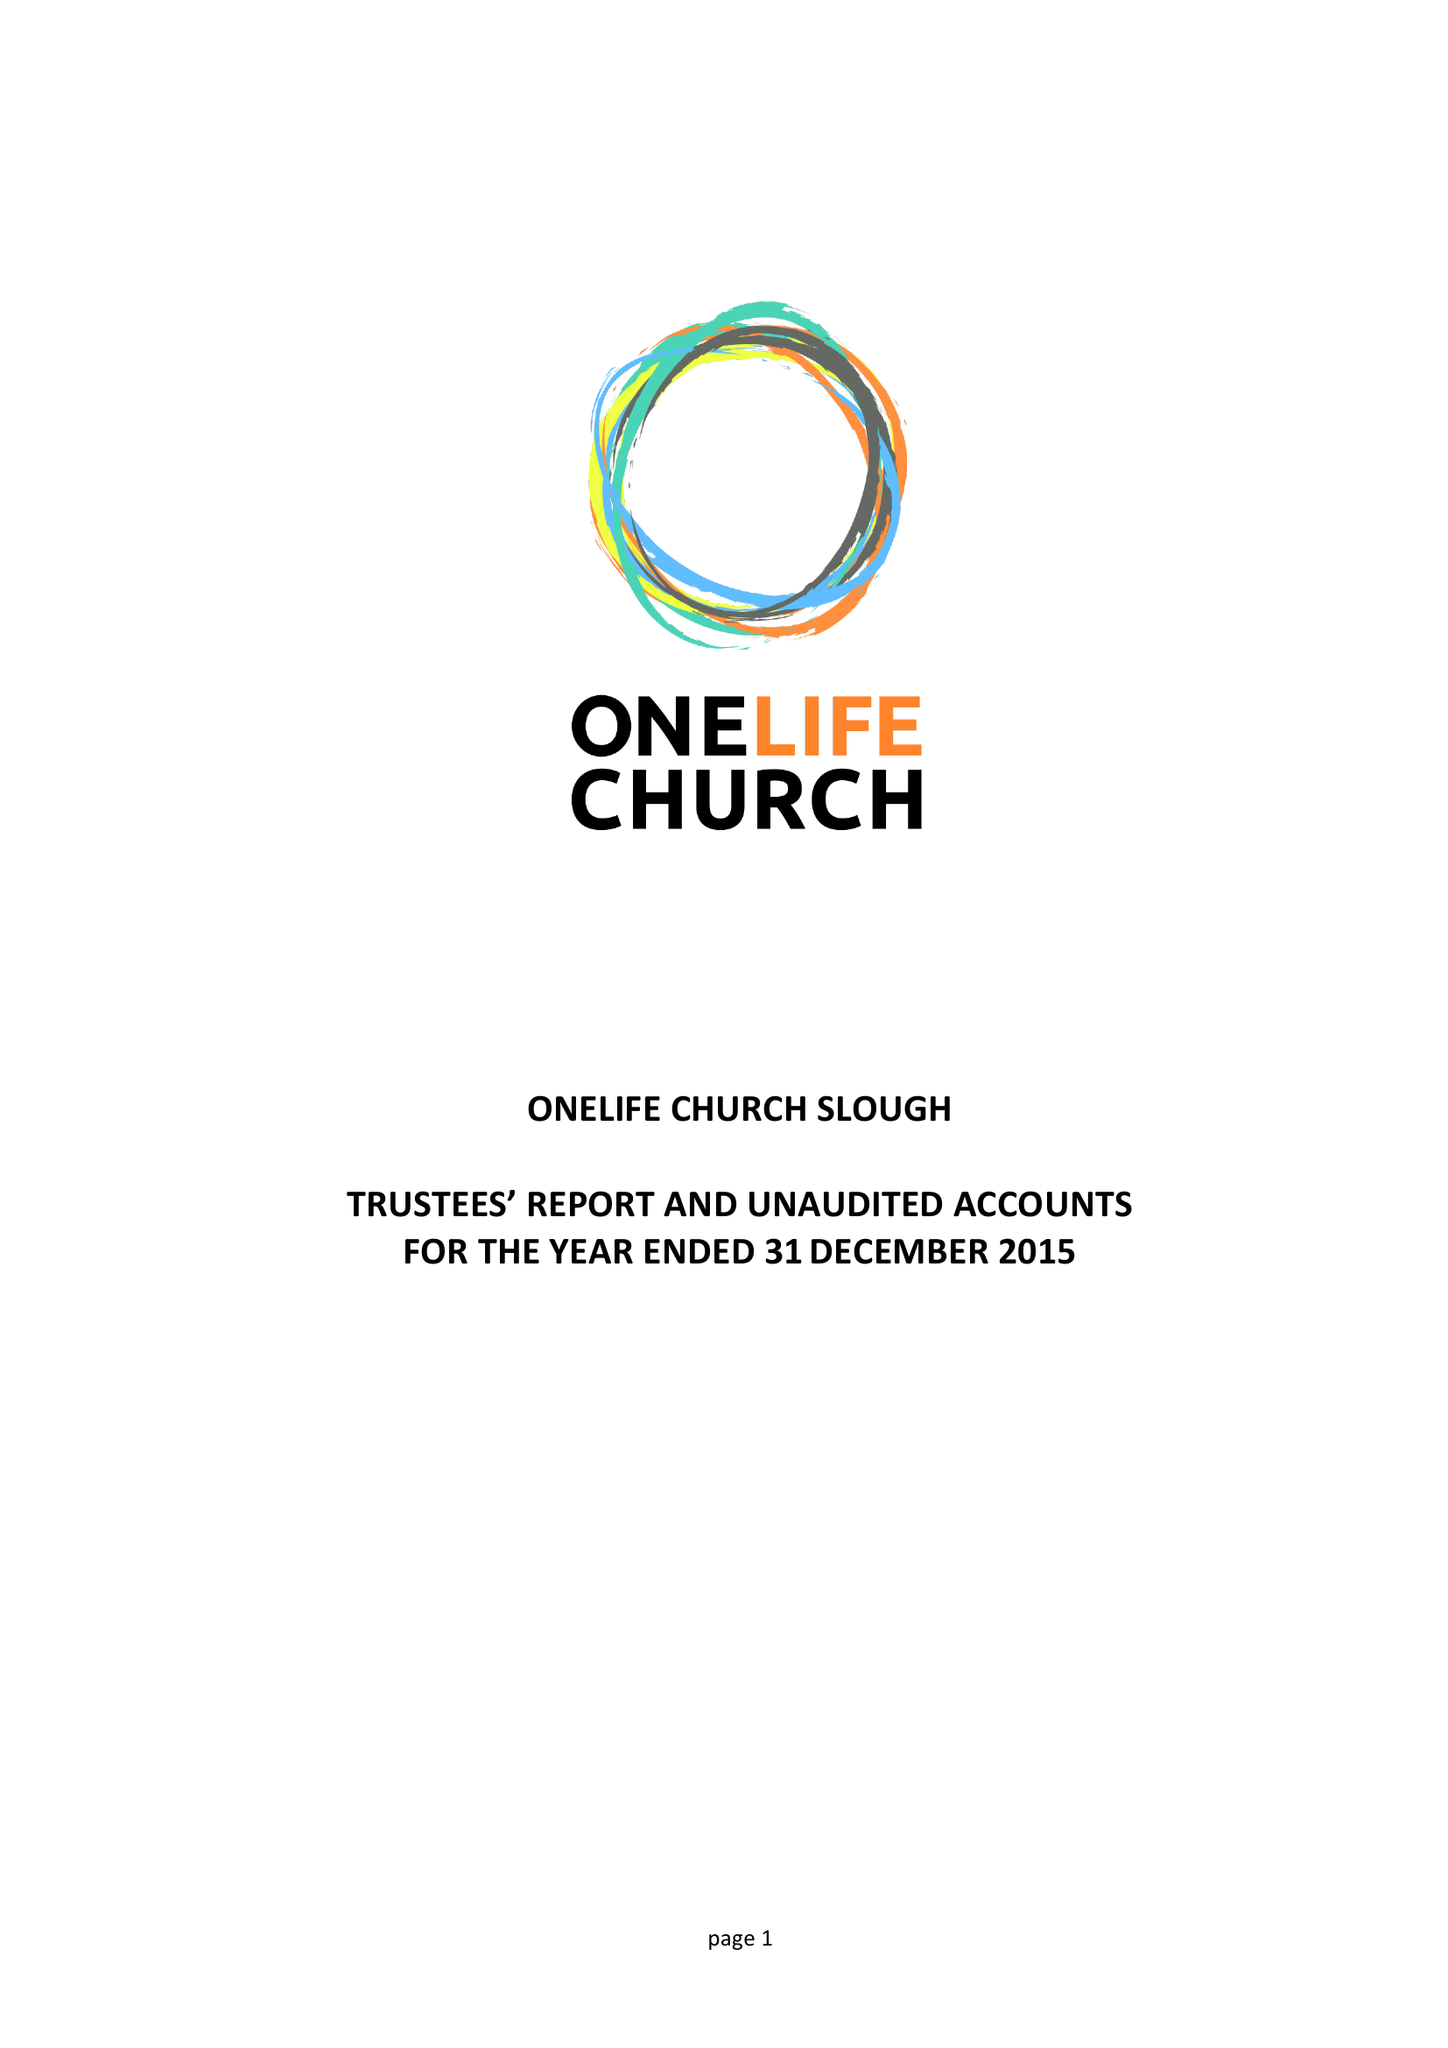What is the value for the income_annually_in_british_pounds?
Answer the question using a single word or phrase. 24456.00 